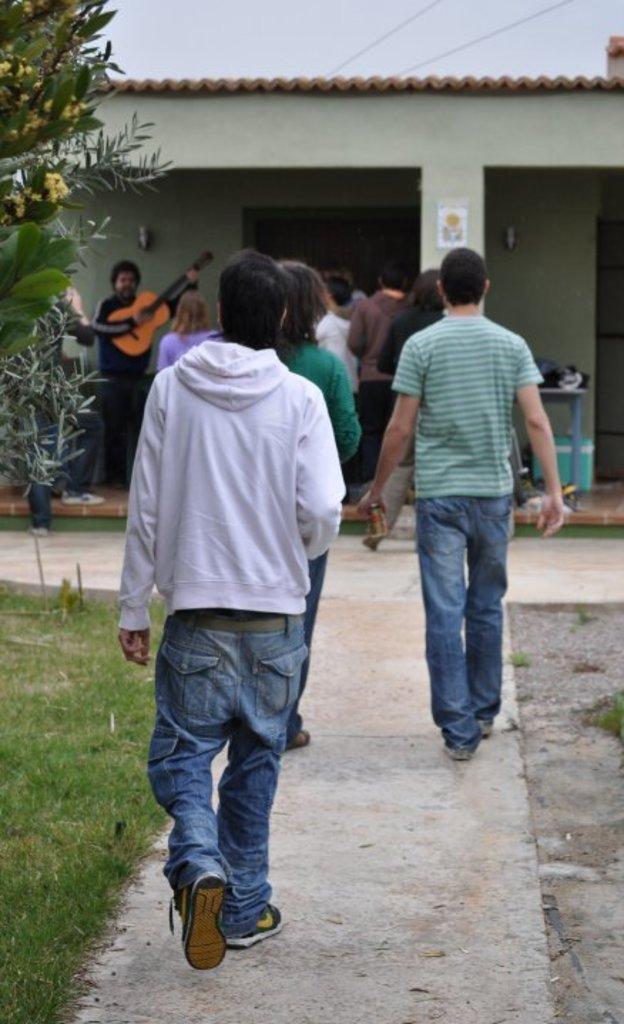How would you summarize this image in a sentence or two? Here we can see a group of people standing ,and here are the persons walking, and here is the grass, and here is the tree, and here is the sky. 